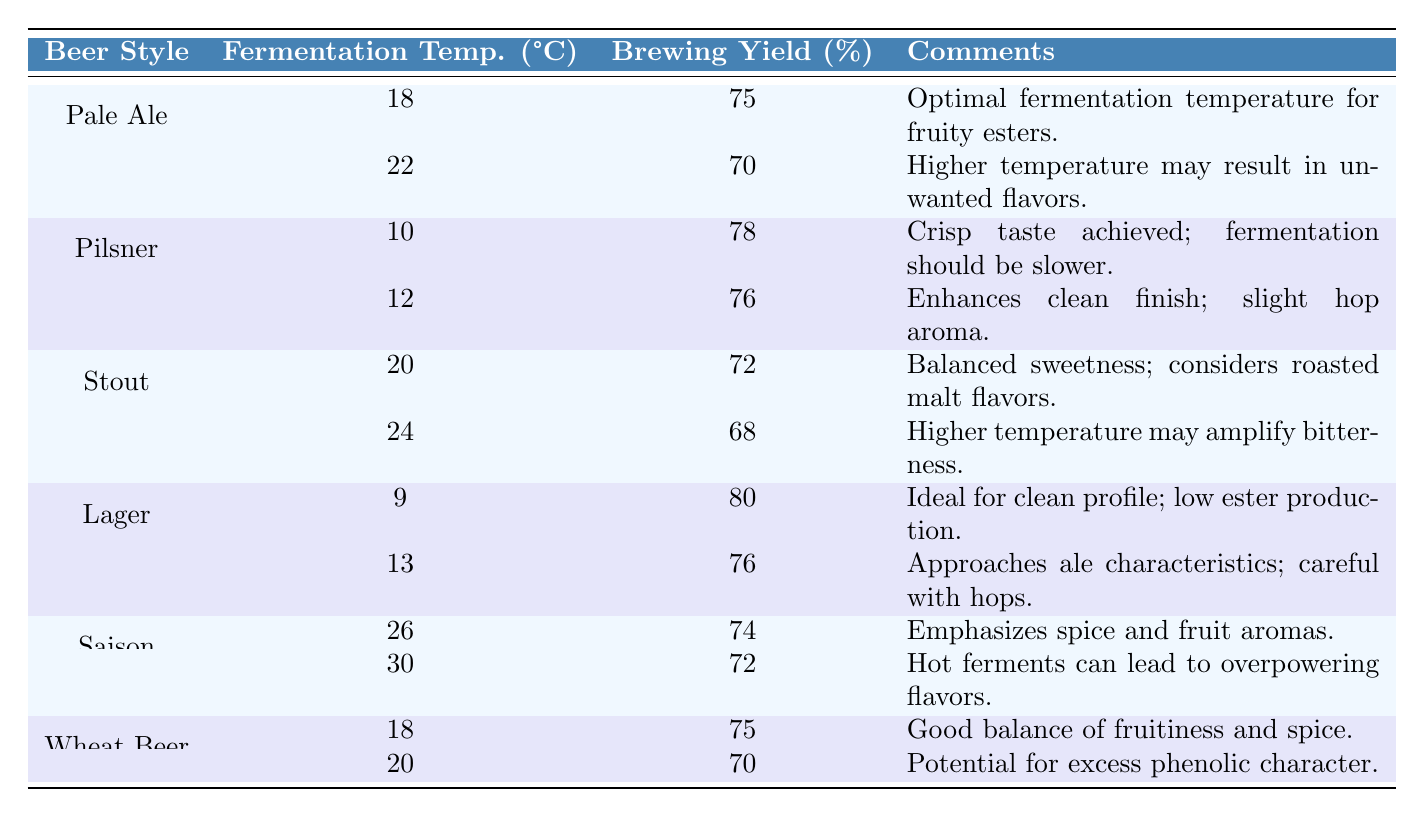What is the brewing yield percentage for Pale Ale at 18°C? The table lists the brewing yield percentage for Pale Ale at 18°C as 75%.
Answer: 75% What are the comments regarding the fermentation temperature for Pilsner at 10°C? According to the table, the comments state that a crisp taste is achieved, and fermentation should be slower.
Answer: Crisp taste achieved; fermentation should be slower Which beer style has the highest brewing yield percentage? By examining the table, Lager at 9°C has the highest brewing yield percentage of 80%.
Answer: Lager at 9°C What is the brewing yield percentage for Stout fermented at 24°C? From the table, the brewing yield percentage for Stout at 24°C is 68%.
Answer: 68% How much lower is the brewing yield percentage for Pale Ale at 22°C compared to at 18°C? The brewing yield percentage for Pale Ale at 18°C is 75% and at 22°C it is 70%. The difference is 75% - 70% = 5%.
Answer: 5% Is the brewing yield percentage for Wheat Beer at 20°C higher than that for Saison at 30°C? The brewing yield percentage for Wheat Beer at 20°C is 70%, while for Saison at 30°C it is 72%. Therefore, 70% is not higher than 72%, making the statement false.
Answer: No What is the average brewing yield percentage across all Lager fermentation temperatures? The brewing yield percentages for Lager are 80% at 9°C and 76% at 13°C. The average is (80 + 76) / 2 = 78%.
Answer: 78% How does the brewing yield percentage for Saison at 26°C compare with that at 30°C? The table shows that Saison at 26°C has a brewing yield percentage of 74%, while at 30°C it is 72%. Thus, 74% is higher than 72%.
Answer: 74% is higher What is the total brewing yield percentage for all the beer styles combined at their respective optimal fermentation temperatures? Adding up the percentages: 75 (Pale Ale at 18°C) + 78 (Pilsner at 10°C) + 72 (Stout at 20°C) + 80 (Lager at 9°C) + 74 (Saison at 26°C) + 75 (Wheat Beer at 18°C) = 454.
Answer: 454 Is it true that all beer styles listed have higher yields at lower fermentation temperatures? Examining the data, Lager has the highest yield at the lowest temperature (9°C), but other styles don't consistently show higher yields at lower temperatures. For example, Pale Ale has a higher yield at 18°C compared to 22°C, but Stout drops yield from 20°C to 24°C. Thus, the statement is false.
Answer: No 